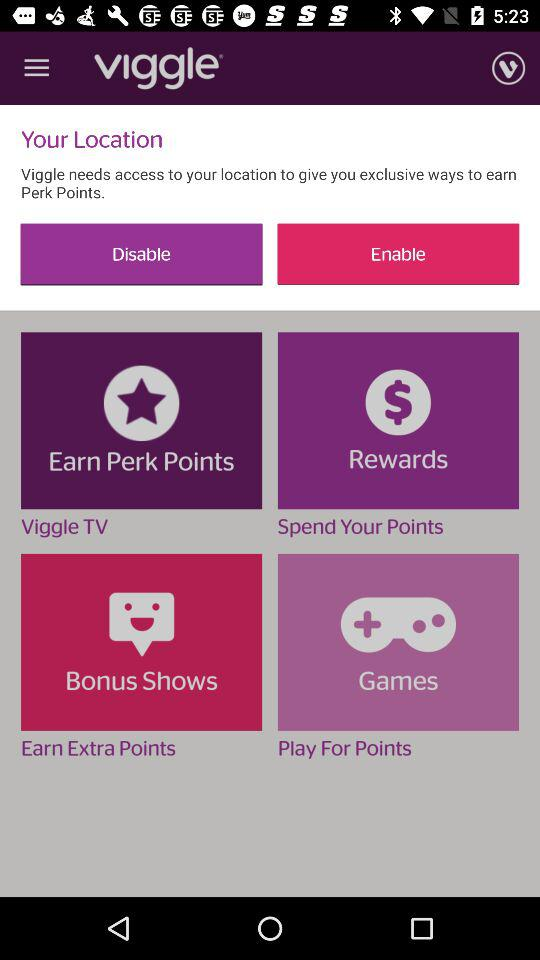What is the name of the application? The name of the application is "Viggle". 